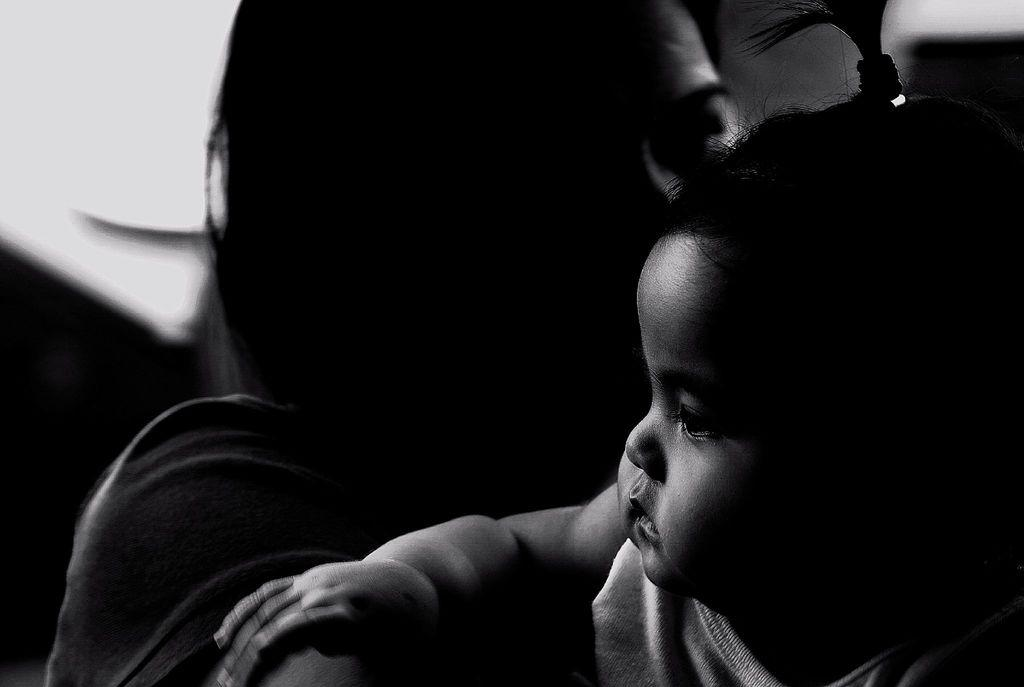What is the main subject of the image? There is a baby in the image. What is the baby wearing? The baby is wearing a dress. What is the color scheme of the image? The image is in black and white. What type of lamp is visible in the image? There is no lamp present in the image; it features a baby wearing a dress in black and white. What holiday is being celebrated in the image? There is no indication of a holiday being celebrated in the image. 